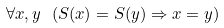Convert formula to latex. <formula><loc_0><loc_0><loc_500><loc_500>\forall x , y \ ( S ( x ) = S ( y ) \Rightarrow x = y )</formula> 